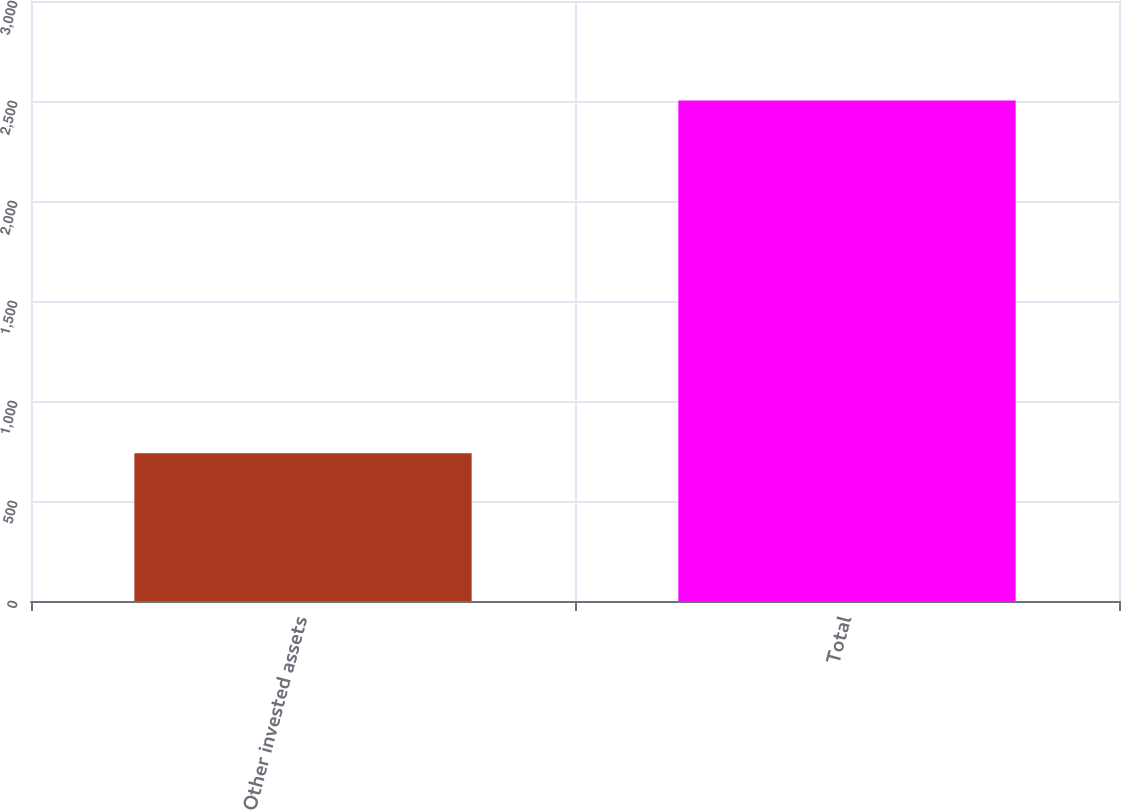Convert chart. <chart><loc_0><loc_0><loc_500><loc_500><bar_chart><fcel>Other invested assets<fcel>Total<nl><fcel>739<fcel>2503<nl></chart> 